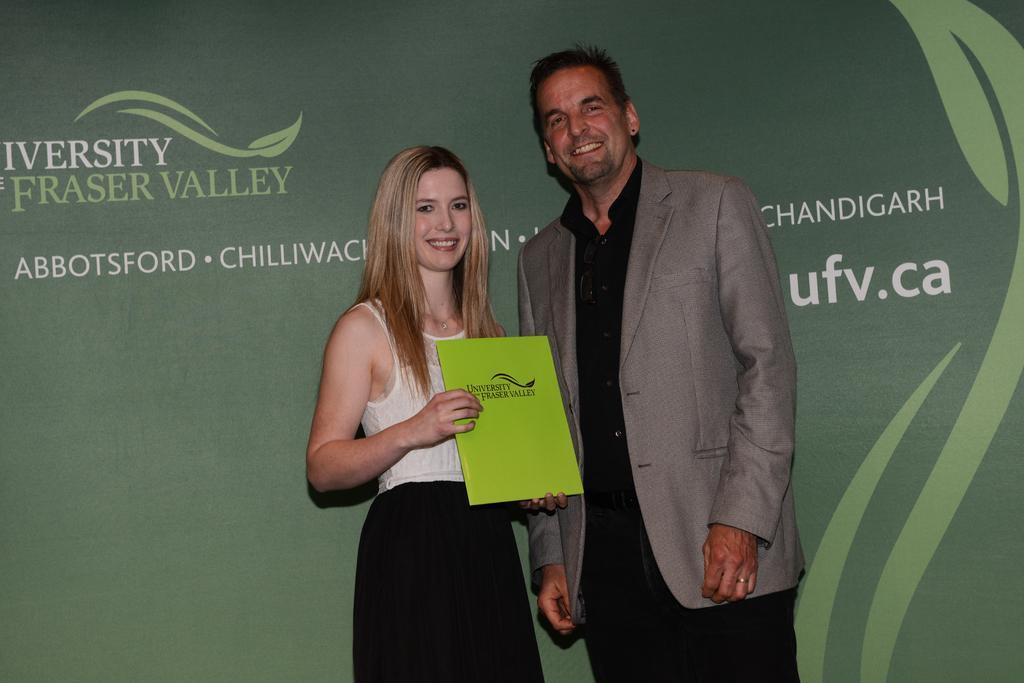Can you describe this image briefly? In this image we can see a man and a woman standing. In that the woman is holding a card which has some text on it. On the backside we can see a banner with some text it. 